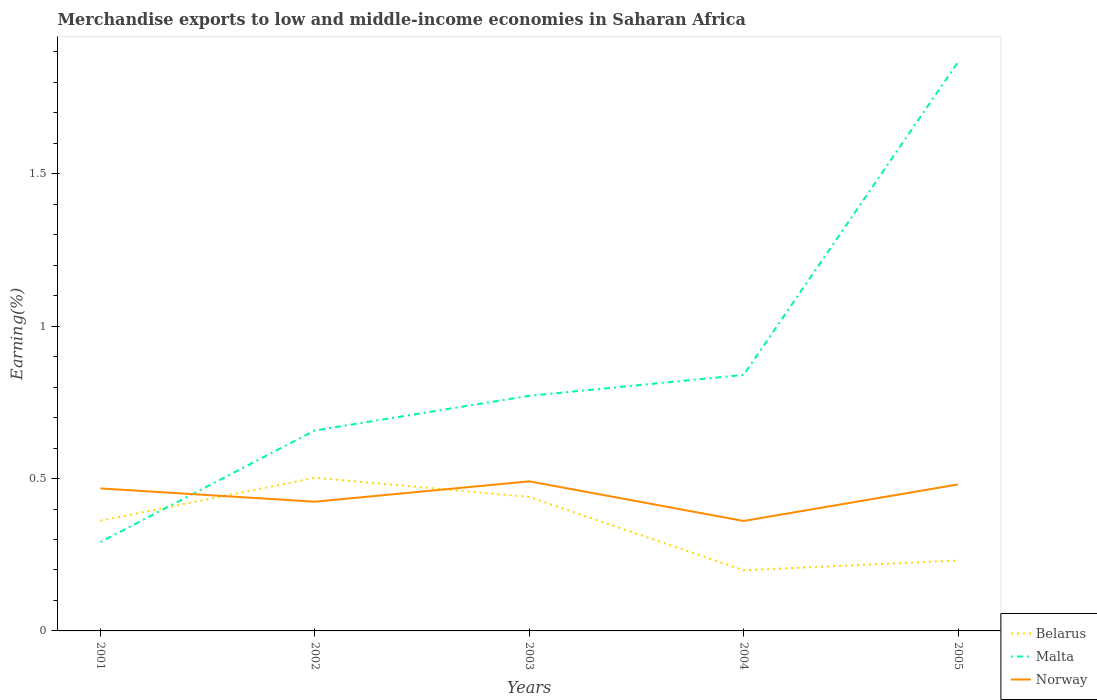Across all years, what is the maximum percentage of amount earned from merchandise exports in Norway?
Offer a terse response. 0.36. What is the total percentage of amount earned from merchandise exports in Belarus in the graph?
Your response must be concise. -0.03. What is the difference between the highest and the second highest percentage of amount earned from merchandise exports in Belarus?
Your answer should be very brief. 0.3. How many years are there in the graph?
Your answer should be compact. 5. How many legend labels are there?
Give a very brief answer. 3. What is the title of the graph?
Make the answer very short. Merchandise exports to low and middle-income economies in Saharan Africa. Does "France" appear as one of the legend labels in the graph?
Make the answer very short. No. What is the label or title of the Y-axis?
Make the answer very short. Earning(%). What is the Earning(%) in Belarus in 2001?
Offer a very short reply. 0.36. What is the Earning(%) in Malta in 2001?
Provide a succinct answer. 0.29. What is the Earning(%) of Norway in 2001?
Offer a terse response. 0.47. What is the Earning(%) of Belarus in 2002?
Keep it short and to the point. 0.5. What is the Earning(%) in Malta in 2002?
Give a very brief answer. 0.66. What is the Earning(%) in Norway in 2002?
Provide a succinct answer. 0.42. What is the Earning(%) in Belarus in 2003?
Offer a terse response. 0.44. What is the Earning(%) in Malta in 2003?
Keep it short and to the point. 0.77. What is the Earning(%) in Norway in 2003?
Your answer should be very brief. 0.49. What is the Earning(%) in Belarus in 2004?
Give a very brief answer. 0.2. What is the Earning(%) of Malta in 2004?
Your response must be concise. 0.84. What is the Earning(%) in Norway in 2004?
Your answer should be very brief. 0.36. What is the Earning(%) of Belarus in 2005?
Ensure brevity in your answer.  0.23. What is the Earning(%) of Malta in 2005?
Offer a very short reply. 1.87. What is the Earning(%) in Norway in 2005?
Provide a succinct answer. 0.48. Across all years, what is the maximum Earning(%) in Belarus?
Offer a terse response. 0.5. Across all years, what is the maximum Earning(%) in Malta?
Make the answer very short. 1.87. Across all years, what is the maximum Earning(%) of Norway?
Offer a very short reply. 0.49. Across all years, what is the minimum Earning(%) of Belarus?
Provide a short and direct response. 0.2. Across all years, what is the minimum Earning(%) in Malta?
Offer a very short reply. 0.29. Across all years, what is the minimum Earning(%) in Norway?
Your answer should be compact. 0.36. What is the total Earning(%) in Belarus in the graph?
Provide a short and direct response. 1.73. What is the total Earning(%) in Malta in the graph?
Offer a terse response. 4.43. What is the total Earning(%) in Norway in the graph?
Your answer should be very brief. 2.22. What is the difference between the Earning(%) of Belarus in 2001 and that in 2002?
Ensure brevity in your answer.  -0.14. What is the difference between the Earning(%) in Malta in 2001 and that in 2002?
Your answer should be compact. -0.37. What is the difference between the Earning(%) in Norway in 2001 and that in 2002?
Offer a terse response. 0.04. What is the difference between the Earning(%) of Belarus in 2001 and that in 2003?
Provide a succinct answer. -0.08. What is the difference between the Earning(%) of Malta in 2001 and that in 2003?
Provide a short and direct response. -0.48. What is the difference between the Earning(%) of Norway in 2001 and that in 2003?
Offer a terse response. -0.02. What is the difference between the Earning(%) of Belarus in 2001 and that in 2004?
Ensure brevity in your answer.  0.16. What is the difference between the Earning(%) of Malta in 2001 and that in 2004?
Keep it short and to the point. -0.55. What is the difference between the Earning(%) in Norway in 2001 and that in 2004?
Give a very brief answer. 0.11. What is the difference between the Earning(%) of Belarus in 2001 and that in 2005?
Provide a succinct answer. 0.13. What is the difference between the Earning(%) in Malta in 2001 and that in 2005?
Your answer should be very brief. -1.58. What is the difference between the Earning(%) of Norway in 2001 and that in 2005?
Make the answer very short. -0.01. What is the difference between the Earning(%) in Belarus in 2002 and that in 2003?
Your answer should be compact. 0.06. What is the difference between the Earning(%) in Malta in 2002 and that in 2003?
Ensure brevity in your answer.  -0.11. What is the difference between the Earning(%) of Norway in 2002 and that in 2003?
Offer a very short reply. -0.07. What is the difference between the Earning(%) of Belarus in 2002 and that in 2004?
Offer a very short reply. 0.3. What is the difference between the Earning(%) of Malta in 2002 and that in 2004?
Give a very brief answer. -0.18. What is the difference between the Earning(%) of Norway in 2002 and that in 2004?
Make the answer very short. 0.06. What is the difference between the Earning(%) in Belarus in 2002 and that in 2005?
Provide a short and direct response. 0.27. What is the difference between the Earning(%) in Malta in 2002 and that in 2005?
Make the answer very short. -1.21. What is the difference between the Earning(%) in Norway in 2002 and that in 2005?
Make the answer very short. -0.06. What is the difference between the Earning(%) in Belarus in 2003 and that in 2004?
Your answer should be compact. 0.24. What is the difference between the Earning(%) of Malta in 2003 and that in 2004?
Make the answer very short. -0.07. What is the difference between the Earning(%) in Norway in 2003 and that in 2004?
Provide a succinct answer. 0.13. What is the difference between the Earning(%) of Belarus in 2003 and that in 2005?
Give a very brief answer. 0.21. What is the difference between the Earning(%) of Malta in 2003 and that in 2005?
Offer a very short reply. -1.1. What is the difference between the Earning(%) of Norway in 2003 and that in 2005?
Your answer should be compact. 0.01. What is the difference between the Earning(%) in Belarus in 2004 and that in 2005?
Your response must be concise. -0.03. What is the difference between the Earning(%) in Malta in 2004 and that in 2005?
Provide a short and direct response. -1.03. What is the difference between the Earning(%) in Norway in 2004 and that in 2005?
Your answer should be very brief. -0.12. What is the difference between the Earning(%) of Belarus in 2001 and the Earning(%) of Malta in 2002?
Make the answer very short. -0.3. What is the difference between the Earning(%) of Belarus in 2001 and the Earning(%) of Norway in 2002?
Keep it short and to the point. -0.06. What is the difference between the Earning(%) of Malta in 2001 and the Earning(%) of Norway in 2002?
Ensure brevity in your answer.  -0.13. What is the difference between the Earning(%) of Belarus in 2001 and the Earning(%) of Malta in 2003?
Provide a succinct answer. -0.41. What is the difference between the Earning(%) in Belarus in 2001 and the Earning(%) in Norway in 2003?
Keep it short and to the point. -0.13. What is the difference between the Earning(%) of Malta in 2001 and the Earning(%) of Norway in 2003?
Offer a terse response. -0.2. What is the difference between the Earning(%) of Belarus in 2001 and the Earning(%) of Malta in 2004?
Your answer should be very brief. -0.48. What is the difference between the Earning(%) in Belarus in 2001 and the Earning(%) in Norway in 2004?
Offer a terse response. 0. What is the difference between the Earning(%) of Malta in 2001 and the Earning(%) of Norway in 2004?
Your response must be concise. -0.07. What is the difference between the Earning(%) in Belarus in 2001 and the Earning(%) in Malta in 2005?
Give a very brief answer. -1.51. What is the difference between the Earning(%) of Belarus in 2001 and the Earning(%) of Norway in 2005?
Offer a terse response. -0.12. What is the difference between the Earning(%) in Malta in 2001 and the Earning(%) in Norway in 2005?
Provide a succinct answer. -0.19. What is the difference between the Earning(%) in Belarus in 2002 and the Earning(%) in Malta in 2003?
Provide a short and direct response. -0.27. What is the difference between the Earning(%) of Belarus in 2002 and the Earning(%) of Norway in 2003?
Give a very brief answer. 0.01. What is the difference between the Earning(%) in Malta in 2002 and the Earning(%) in Norway in 2003?
Give a very brief answer. 0.17. What is the difference between the Earning(%) in Belarus in 2002 and the Earning(%) in Malta in 2004?
Offer a very short reply. -0.34. What is the difference between the Earning(%) of Belarus in 2002 and the Earning(%) of Norway in 2004?
Your answer should be compact. 0.14. What is the difference between the Earning(%) of Malta in 2002 and the Earning(%) of Norway in 2004?
Keep it short and to the point. 0.3. What is the difference between the Earning(%) of Belarus in 2002 and the Earning(%) of Malta in 2005?
Your response must be concise. -1.36. What is the difference between the Earning(%) of Belarus in 2002 and the Earning(%) of Norway in 2005?
Provide a succinct answer. 0.02. What is the difference between the Earning(%) of Malta in 2002 and the Earning(%) of Norway in 2005?
Ensure brevity in your answer.  0.18. What is the difference between the Earning(%) of Belarus in 2003 and the Earning(%) of Malta in 2004?
Provide a short and direct response. -0.4. What is the difference between the Earning(%) in Belarus in 2003 and the Earning(%) in Norway in 2004?
Offer a terse response. 0.08. What is the difference between the Earning(%) of Malta in 2003 and the Earning(%) of Norway in 2004?
Ensure brevity in your answer.  0.41. What is the difference between the Earning(%) of Belarus in 2003 and the Earning(%) of Malta in 2005?
Your answer should be compact. -1.43. What is the difference between the Earning(%) of Belarus in 2003 and the Earning(%) of Norway in 2005?
Give a very brief answer. -0.04. What is the difference between the Earning(%) in Malta in 2003 and the Earning(%) in Norway in 2005?
Keep it short and to the point. 0.29. What is the difference between the Earning(%) of Belarus in 2004 and the Earning(%) of Malta in 2005?
Your response must be concise. -1.67. What is the difference between the Earning(%) in Belarus in 2004 and the Earning(%) in Norway in 2005?
Your answer should be very brief. -0.28. What is the difference between the Earning(%) in Malta in 2004 and the Earning(%) in Norway in 2005?
Your answer should be very brief. 0.36. What is the average Earning(%) of Belarus per year?
Ensure brevity in your answer.  0.35. What is the average Earning(%) in Malta per year?
Offer a very short reply. 0.89. What is the average Earning(%) of Norway per year?
Provide a short and direct response. 0.44. In the year 2001, what is the difference between the Earning(%) in Belarus and Earning(%) in Malta?
Ensure brevity in your answer.  0.07. In the year 2001, what is the difference between the Earning(%) of Belarus and Earning(%) of Norway?
Your answer should be compact. -0.11. In the year 2001, what is the difference between the Earning(%) of Malta and Earning(%) of Norway?
Provide a short and direct response. -0.18. In the year 2002, what is the difference between the Earning(%) of Belarus and Earning(%) of Malta?
Your response must be concise. -0.16. In the year 2002, what is the difference between the Earning(%) of Belarus and Earning(%) of Norway?
Make the answer very short. 0.08. In the year 2002, what is the difference between the Earning(%) of Malta and Earning(%) of Norway?
Provide a succinct answer. 0.23. In the year 2003, what is the difference between the Earning(%) in Belarus and Earning(%) in Malta?
Ensure brevity in your answer.  -0.33. In the year 2003, what is the difference between the Earning(%) in Belarus and Earning(%) in Norway?
Provide a short and direct response. -0.05. In the year 2003, what is the difference between the Earning(%) of Malta and Earning(%) of Norway?
Provide a succinct answer. 0.28. In the year 2004, what is the difference between the Earning(%) in Belarus and Earning(%) in Malta?
Make the answer very short. -0.64. In the year 2004, what is the difference between the Earning(%) in Belarus and Earning(%) in Norway?
Offer a very short reply. -0.16. In the year 2004, what is the difference between the Earning(%) in Malta and Earning(%) in Norway?
Provide a succinct answer. 0.48. In the year 2005, what is the difference between the Earning(%) of Belarus and Earning(%) of Malta?
Provide a short and direct response. -1.64. In the year 2005, what is the difference between the Earning(%) of Belarus and Earning(%) of Norway?
Provide a succinct answer. -0.25. In the year 2005, what is the difference between the Earning(%) in Malta and Earning(%) in Norway?
Offer a very short reply. 1.39. What is the ratio of the Earning(%) of Belarus in 2001 to that in 2002?
Provide a short and direct response. 0.72. What is the ratio of the Earning(%) in Malta in 2001 to that in 2002?
Give a very brief answer. 0.44. What is the ratio of the Earning(%) of Norway in 2001 to that in 2002?
Your answer should be compact. 1.1. What is the ratio of the Earning(%) in Belarus in 2001 to that in 2003?
Ensure brevity in your answer.  0.82. What is the ratio of the Earning(%) in Malta in 2001 to that in 2003?
Provide a short and direct response. 0.38. What is the ratio of the Earning(%) in Norway in 2001 to that in 2003?
Keep it short and to the point. 0.95. What is the ratio of the Earning(%) in Belarus in 2001 to that in 2004?
Provide a succinct answer. 1.82. What is the ratio of the Earning(%) of Malta in 2001 to that in 2004?
Ensure brevity in your answer.  0.35. What is the ratio of the Earning(%) in Norway in 2001 to that in 2004?
Your response must be concise. 1.3. What is the ratio of the Earning(%) in Belarus in 2001 to that in 2005?
Provide a succinct answer. 1.57. What is the ratio of the Earning(%) of Malta in 2001 to that in 2005?
Provide a succinct answer. 0.16. What is the ratio of the Earning(%) in Norway in 2001 to that in 2005?
Offer a very short reply. 0.97. What is the ratio of the Earning(%) of Belarus in 2002 to that in 2003?
Keep it short and to the point. 1.14. What is the ratio of the Earning(%) of Malta in 2002 to that in 2003?
Your response must be concise. 0.85. What is the ratio of the Earning(%) of Norway in 2002 to that in 2003?
Your response must be concise. 0.86. What is the ratio of the Earning(%) of Belarus in 2002 to that in 2004?
Your answer should be compact. 2.52. What is the ratio of the Earning(%) in Malta in 2002 to that in 2004?
Keep it short and to the point. 0.78. What is the ratio of the Earning(%) in Norway in 2002 to that in 2004?
Your answer should be very brief. 1.18. What is the ratio of the Earning(%) in Belarus in 2002 to that in 2005?
Your answer should be compact. 2.18. What is the ratio of the Earning(%) of Malta in 2002 to that in 2005?
Your answer should be very brief. 0.35. What is the ratio of the Earning(%) in Norway in 2002 to that in 2005?
Make the answer very short. 0.88. What is the ratio of the Earning(%) in Belarus in 2003 to that in 2004?
Your response must be concise. 2.21. What is the ratio of the Earning(%) of Malta in 2003 to that in 2004?
Your answer should be compact. 0.92. What is the ratio of the Earning(%) in Norway in 2003 to that in 2004?
Offer a terse response. 1.36. What is the ratio of the Earning(%) of Belarus in 2003 to that in 2005?
Your answer should be very brief. 1.9. What is the ratio of the Earning(%) of Malta in 2003 to that in 2005?
Your response must be concise. 0.41. What is the ratio of the Earning(%) in Norway in 2003 to that in 2005?
Offer a terse response. 1.02. What is the ratio of the Earning(%) in Belarus in 2004 to that in 2005?
Provide a short and direct response. 0.86. What is the ratio of the Earning(%) of Malta in 2004 to that in 2005?
Keep it short and to the point. 0.45. What is the ratio of the Earning(%) in Norway in 2004 to that in 2005?
Your answer should be very brief. 0.75. What is the difference between the highest and the second highest Earning(%) in Belarus?
Keep it short and to the point. 0.06. What is the difference between the highest and the second highest Earning(%) of Malta?
Offer a terse response. 1.03. What is the difference between the highest and the second highest Earning(%) in Norway?
Your answer should be very brief. 0.01. What is the difference between the highest and the lowest Earning(%) of Belarus?
Offer a very short reply. 0.3. What is the difference between the highest and the lowest Earning(%) in Malta?
Give a very brief answer. 1.58. What is the difference between the highest and the lowest Earning(%) in Norway?
Offer a very short reply. 0.13. 